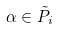Convert formula to latex. <formula><loc_0><loc_0><loc_500><loc_500>\alpha \in \tilde { P } _ { i }</formula> 